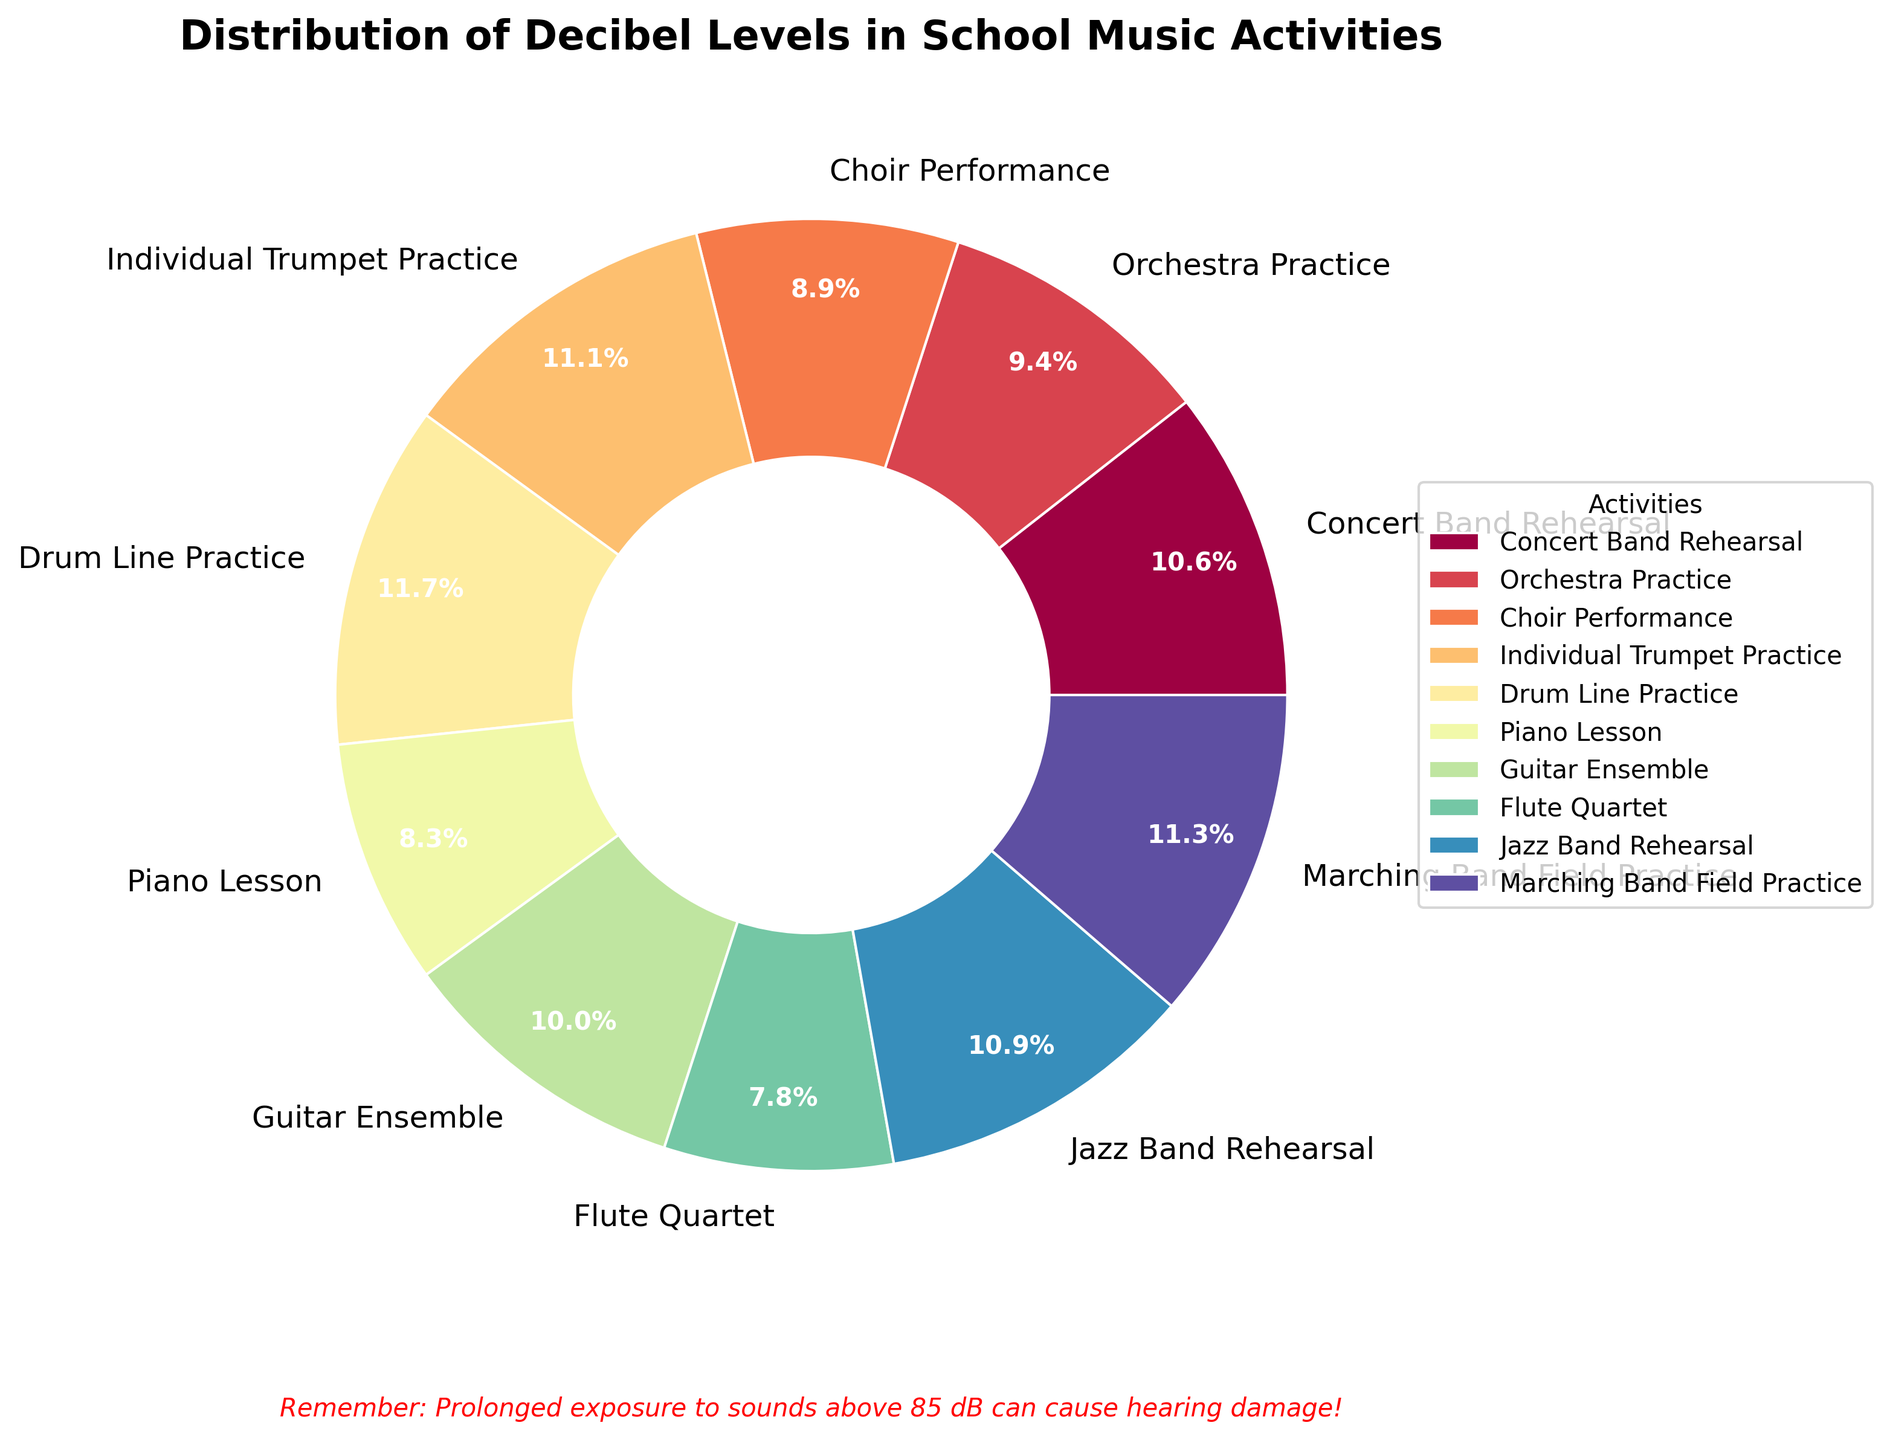What percentage of the decibel levels does Drum Line Practice account for? To find this, look at the pie chart slice labeled "Drum Line Practice" and check the percentage value displayed.
Answer: 14.3% Which activity has the highest decibel level and what is its percentage in the chart? Identify the activity with the highest decibel level from the pie chart slice with the highest value, and note its percentage. "Drum Line Practice" has the highest decibel level with 14.3%.
Answer: Drum Line Practice, 14.3% How does the decibel level of the Piano Lesson compare to the Flute Quartet? Compare the slices labeled "Piano Lesson" and "Flute Quartet" and note their respective decibel levels. Piano Lesson is 75 dB and Flute Quartet is 70 dB, so Piano Lesson is 5 dB higher.
Answer: Piano Lesson is 5 dB higher Which activity has the lowest decibel level and what color is its slice? Find the pie chart slice with the smallest percentage and note both the activity and the color associated with it. "Flute Quartet" has the lowest decibel level and its slice is colored in a light color.
Answer: Flute Quartet, light color What’s the combined percentage of Marching Band Field Practice and Jazz Band Rehearsal? Sum the percentages of the slices labeled "Marching Band Field Practice" and "Jazz Band Rehearsal." From the chart, Marching Band Field Practice is 14.6% and Jazz Band Rehearsal is 14.0%. Combined, they are 28.6%.
Answer: 28.6% How much greater is the decibel level of Individual Trumpet Practice compared to the average decibel level across all activities? Calculate the average decibel level across all activities and then find the difference between this average and the decibel level of Individual Trumpet Practice. The average decibel level is calculated by summing all decibels (95 + 85 + 80 + 100 + 105 + 75 + 90 + 70 + 98 + 102) = 900, then dividing by 10, which gives 90 dB. The difference between Individual Trumpet Practice (100 dB) and the average (90 dB) is 10 dB.
Answer: 10 dB Which activities have decibel levels above 90 dB and what is their combined percentage of the chart? Identify the activities with decibel levels above 90 dB from the chart and sum their percentages. These activities and their percentages are Concert Band Rehearsal (95 dB, 11.8%), Individual Trumpet Practice (100 dB, 12.1%), Drum Line Practice (105 dB, 14.3%), Jazz Band Rehearsal (98 dB, 14.0%), and Marching Band Field Practice (102 dB, 14.6%). Combined, they are 66.8%.
Answer: 66.8% Which activities have decibel levels below 85 dB? From the pie chart, identify the activities labeled with decibel levels below 85 dB. These activities are Piano Lesson (75 dB) and Flute Quartet (70 dB).
Answer: Piano Lesson and Flute Quartet If the recommendation is to use hearing protection for activities above 85 dB, how many activities would require it according to the chart? Count the number of activities with decibel levels above 85 dB on the chart. These activities are Concert Band Rehearsal, Individual Trumpet Practice, Drum Line Practice, Guitar Ensemble, Jazz Band Rehearsal, and Marching Band Field Practice.
Answer: 6 What’s the difference in decibel level between the quietest and loudest activities? Identify the quietest and loudest activities from the chart, then find the difference between their decibel levels. The Flute Quartet is the quietest at 70 dB, and Drum Line Practice is the loudest at 105 dB. The difference is 105 - 70 = 35 dB.
Answer: 35 dB 